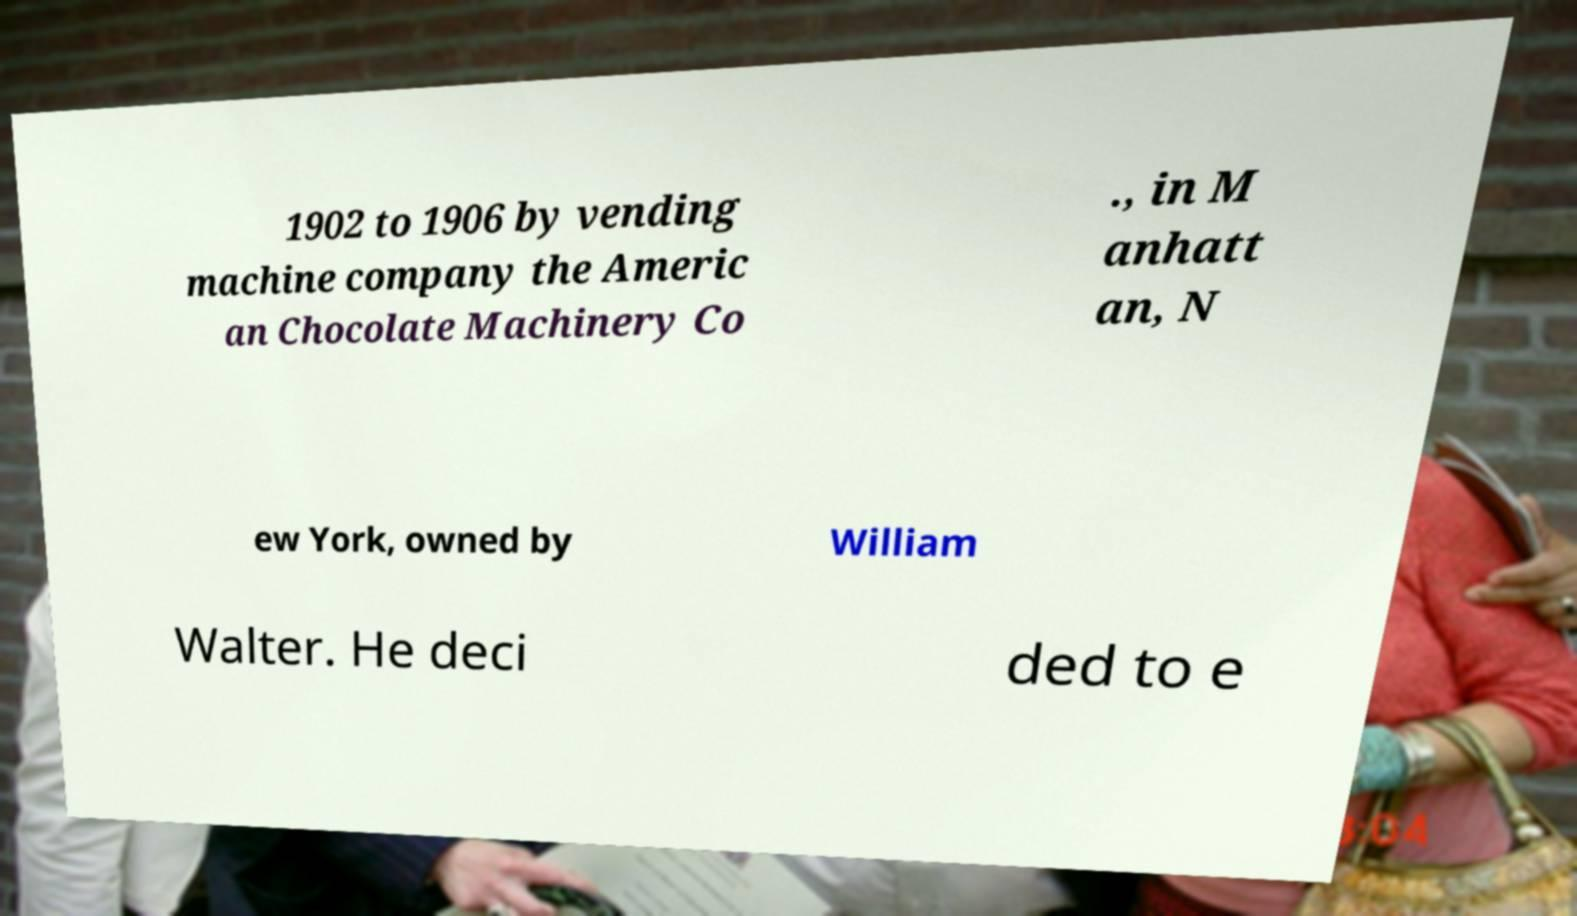I need the written content from this picture converted into text. Can you do that? 1902 to 1906 by vending machine company the Americ an Chocolate Machinery Co ., in M anhatt an, N ew York, owned by William Walter. He deci ded to e 